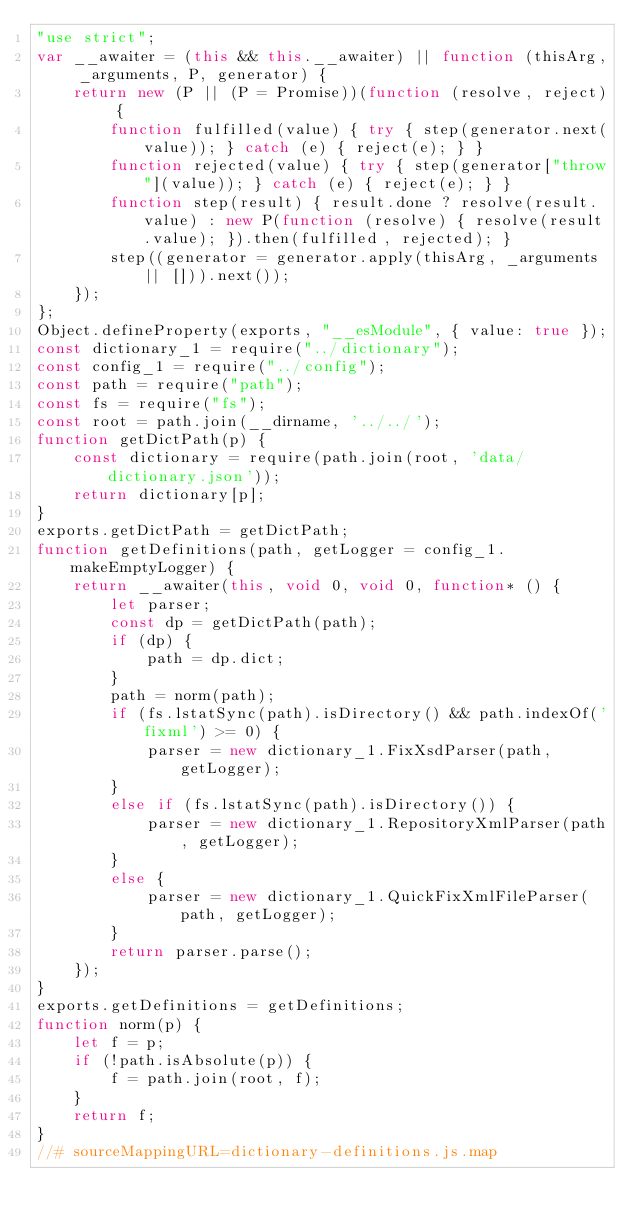Convert code to text. <code><loc_0><loc_0><loc_500><loc_500><_JavaScript_>"use strict";
var __awaiter = (this && this.__awaiter) || function (thisArg, _arguments, P, generator) {
    return new (P || (P = Promise))(function (resolve, reject) {
        function fulfilled(value) { try { step(generator.next(value)); } catch (e) { reject(e); } }
        function rejected(value) { try { step(generator["throw"](value)); } catch (e) { reject(e); } }
        function step(result) { result.done ? resolve(result.value) : new P(function (resolve) { resolve(result.value); }).then(fulfilled, rejected); }
        step((generator = generator.apply(thisArg, _arguments || [])).next());
    });
};
Object.defineProperty(exports, "__esModule", { value: true });
const dictionary_1 = require("../dictionary");
const config_1 = require("../config");
const path = require("path");
const fs = require("fs");
const root = path.join(__dirname, '../../');
function getDictPath(p) {
    const dictionary = require(path.join(root, 'data/dictionary.json'));
    return dictionary[p];
}
exports.getDictPath = getDictPath;
function getDefinitions(path, getLogger = config_1.makeEmptyLogger) {
    return __awaiter(this, void 0, void 0, function* () {
        let parser;
        const dp = getDictPath(path);
        if (dp) {
            path = dp.dict;
        }
        path = norm(path);
        if (fs.lstatSync(path).isDirectory() && path.indexOf('fixml') >= 0) {
            parser = new dictionary_1.FixXsdParser(path, getLogger);
        }
        else if (fs.lstatSync(path).isDirectory()) {
            parser = new dictionary_1.RepositoryXmlParser(path, getLogger);
        }
        else {
            parser = new dictionary_1.QuickFixXmlFileParser(path, getLogger);
        }
        return parser.parse();
    });
}
exports.getDefinitions = getDefinitions;
function norm(p) {
    let f = p;
    if (!path.isAbsolute(p)) {
        f = path.join(root, f);
    }
    return f;
}
//# sourceMappingURL=dictionary-definitions.js.map</code> 